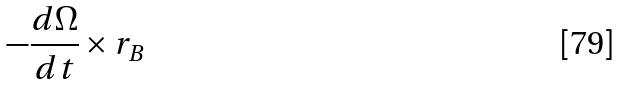<formula> <loc_0><loc_0><loc_500><loc_500>- \frac { d \Omega } { d t } \times r _ { B }</formula> 